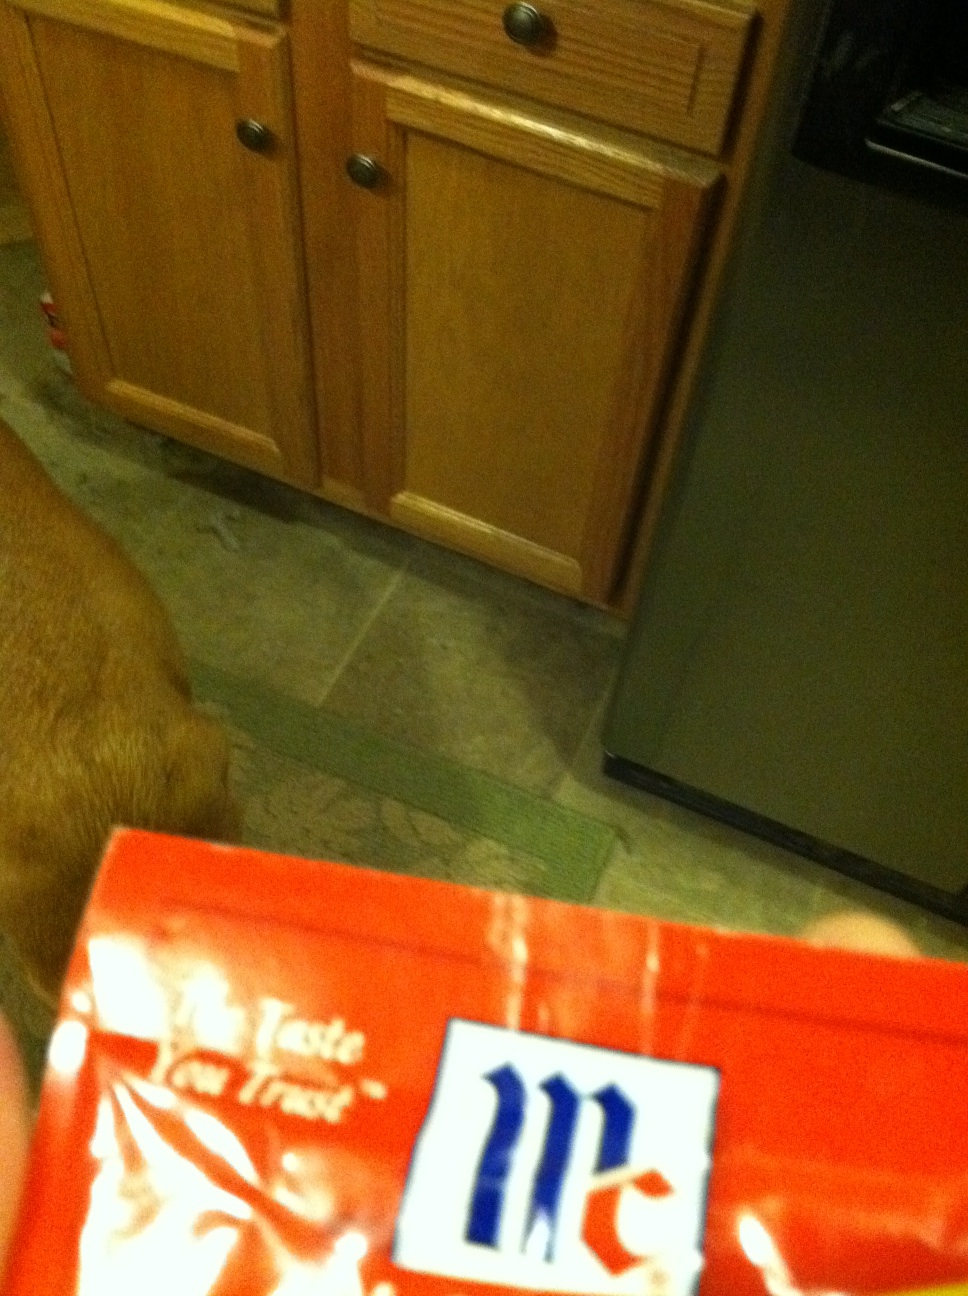Is this kind of packet usually found in regular grocery stores? Yes, packets similar to this one are commonly available in most grocery stores, often located in the cooking aids or international food sections, depending on the type of sauce or seasoning mix they contain. 